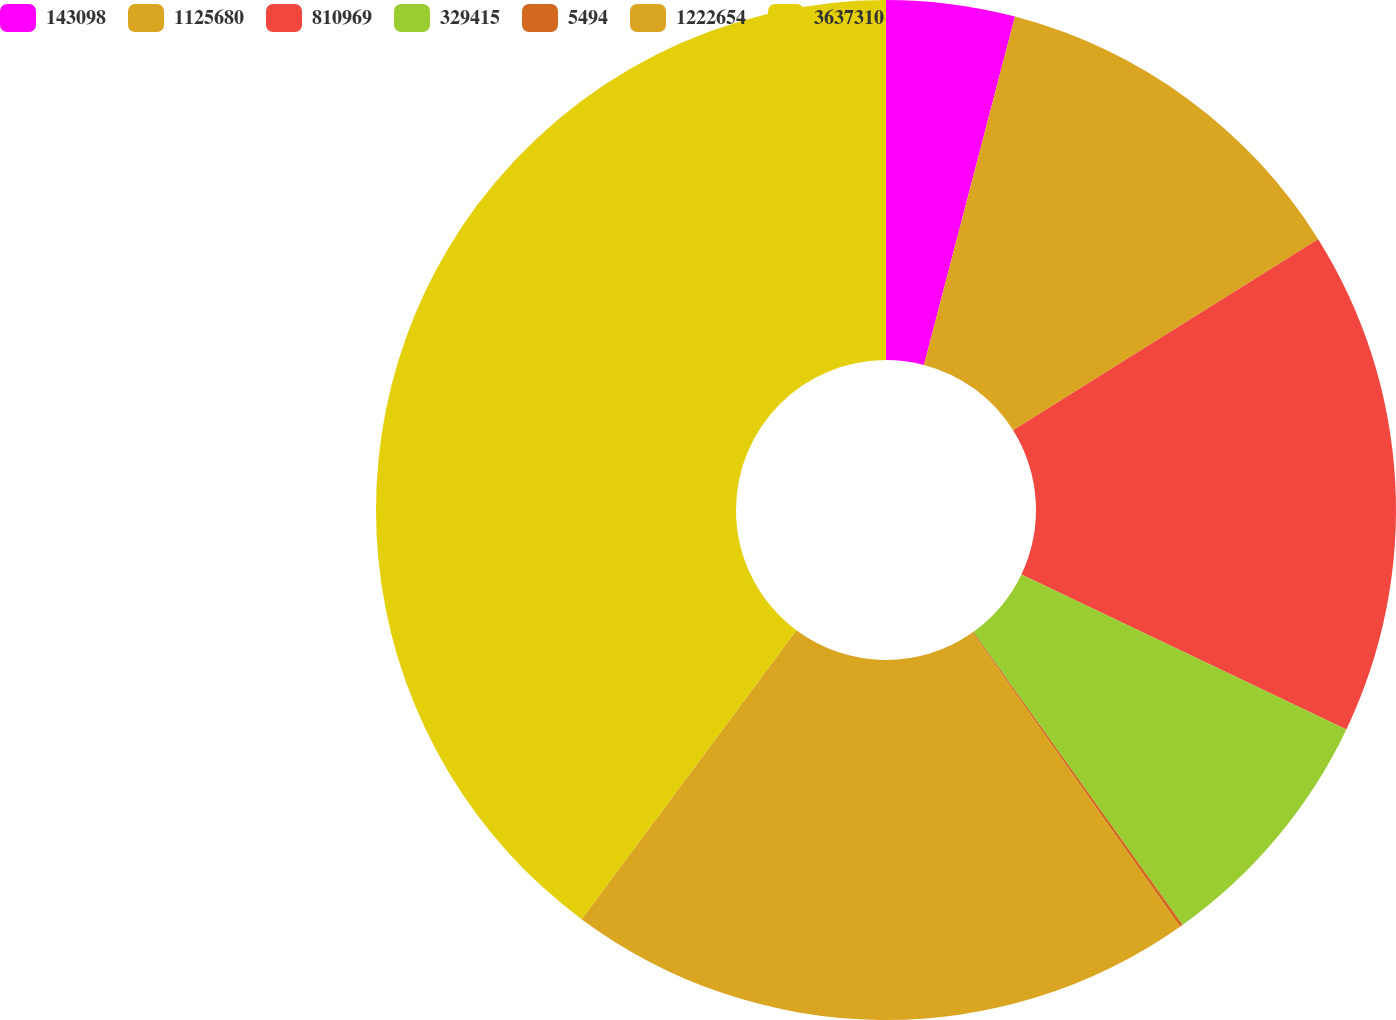Convert chart. <chart><loc_0><loc_0><loc_500><loc_500><pie_chart><fcel>143098<fcel>1125680<fcel>810969<fcel>329415<fcel>5494<fcel>1222654<fcel>3637310<nl><fcel>4.07%<fcel>12.02%<fcel>15.99%<fcel>8.04%<fcel>0.1%<fcel>19.96%<fcel>39.82%<nl></chart> 